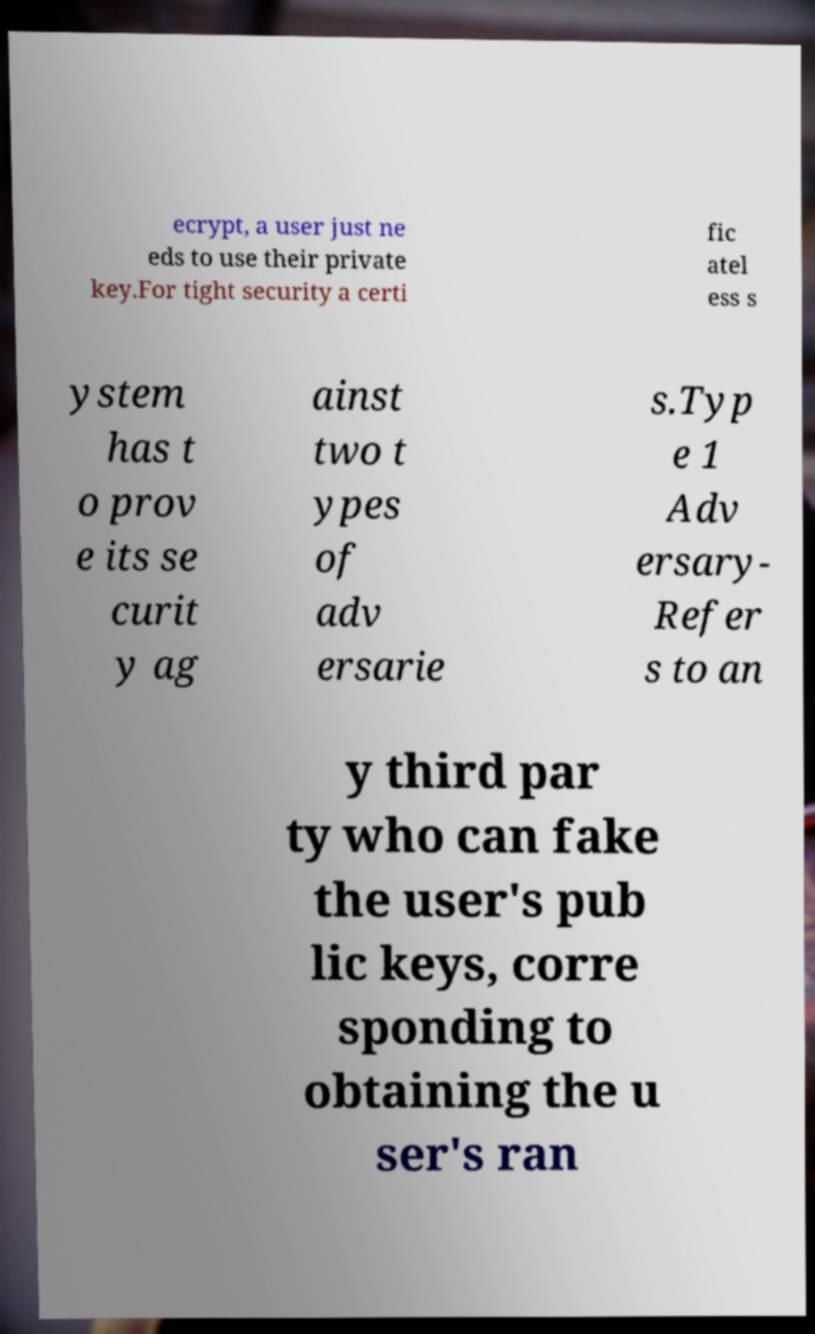Can you accurately transcribe the text from the provided image for me? ecrypt, a user just ne eds to use their private key.For tight security a certi fic atel ess s ystem has t o prov e its se curit y ag ainst two t ypes of adv ersarie s.Typ e 1 Adv ersary- Refer s to an y third par ty who can fake the user's pub lic keys, corre sponding to obtaining the u ser's ran 